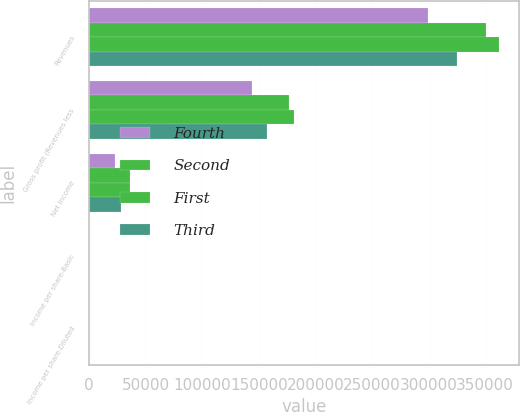<chart> <loc_0><loc_0><loc_500><loc_500><stacked_bar_chart><ecel><fcel>Revenues<fcel>Gross profit (Revenues less<fcel>Net income<fcel>Income per share-Basic<fcel>Income per share-Diluted<nl><fcel>Fourth<fcel>299714<fcel>144108<fcel>23179<fcel>0.16<fcel>0.16<nl><fcel>Second<fcel>350798<fcel>176437<fcel>35994<fcel>0.25<fcel>0.25<nl><fcel>First<fcel>362155<fcel>181020<fcel>36200<fcel>0.25<fcel>0.25<nl><fcel>Third<fcel>324707<fcel>157350<fcel>27957<fcel>0.19<fcel>0.19<nl></chart> 